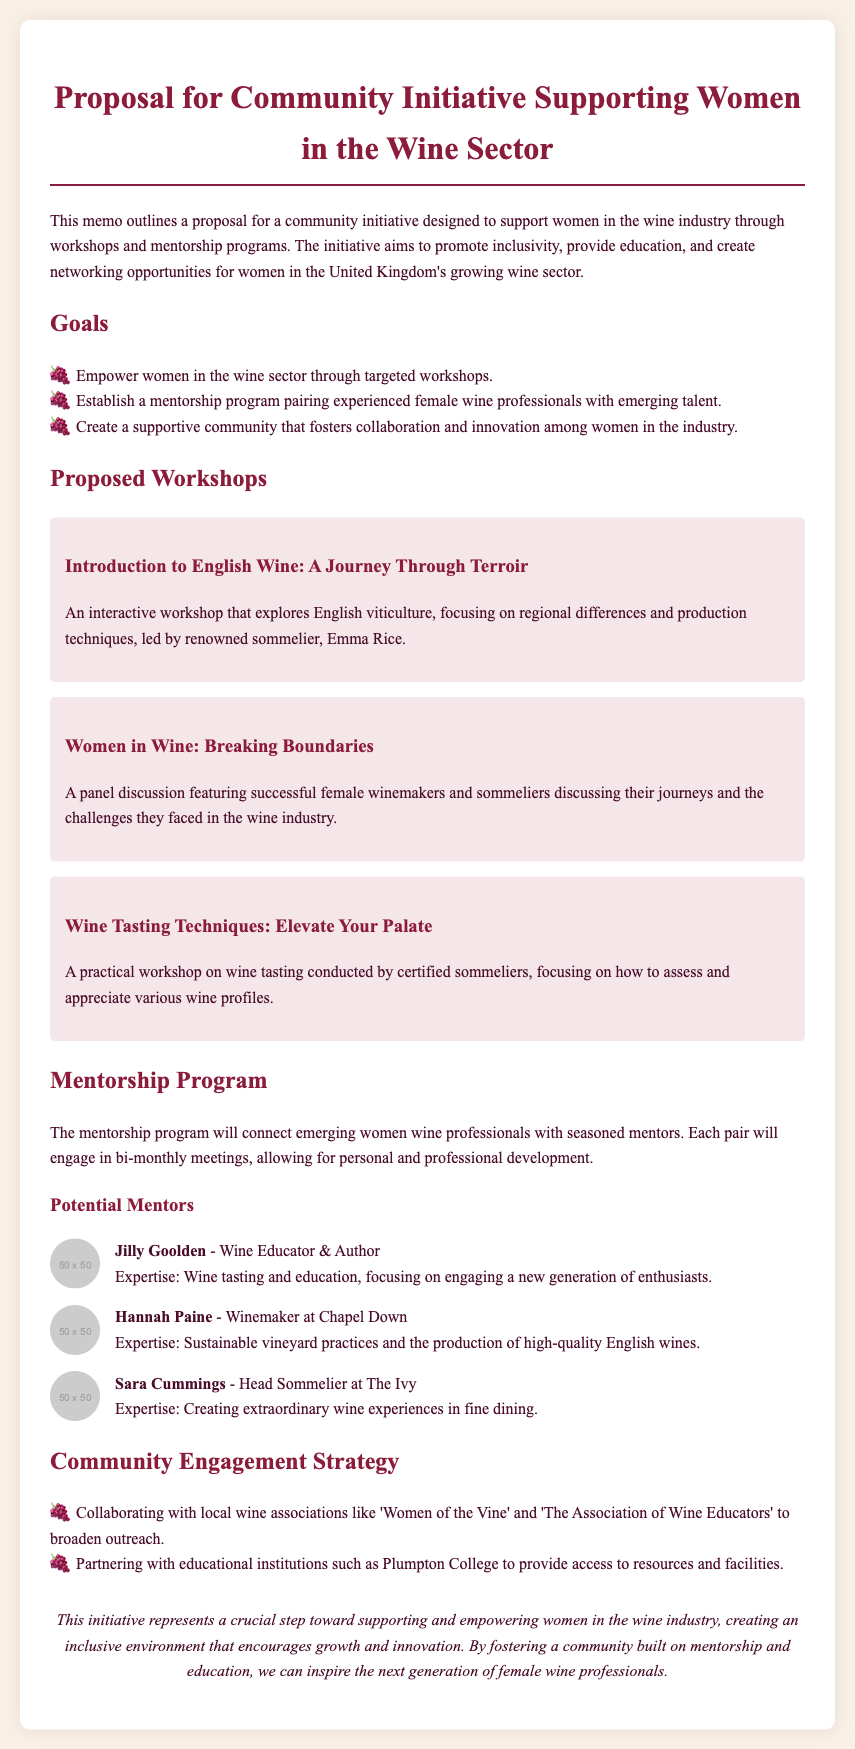What is the title of the proposal? The title of the proposal is indicated at the top of the document.
Answer: Proposal for Community Initiative Supporting Women in the Wine Sector Who is leading the workshop titled "Introduction to English Wine: A Journey Through Terroir"? The workshop leader is mentioned in the description of the workshop.
Answer: Emma Rice What is the purpose of the mentorship program? The purpose is summarized in a specific section discussing the mentorship program.
Answer: Connect emerging women wine professionals with seasoned mentors How many women are listed as mentors in the proposal? The document provides a specific count of mentors under the mentorship program section.
Answer: Three What is one of the goals of the community initiative? Goals are listed in a section dedicated to outlining the initiative's objectives.
Answer: Empower women in the wine sector Which institution is mentioned as a partner for resources and facilities? The document specifically names an educational institution related to community engagement.
Answer: Plumpton College What type of workshop is "Wine Tasting Techniques: Elevate Your Palate"? The format of the workshop is described clearly in its title and description.
Answer: Practical workshop What association is mentioned for collaboration in the community engagement strategy? The document names a specific association aimed at broadening outreach.
Answer: Women of the Vine Where is the initiative aimed to support women? The document specifies a geographic location regarding the target audience.
Answer: United Kingdom 